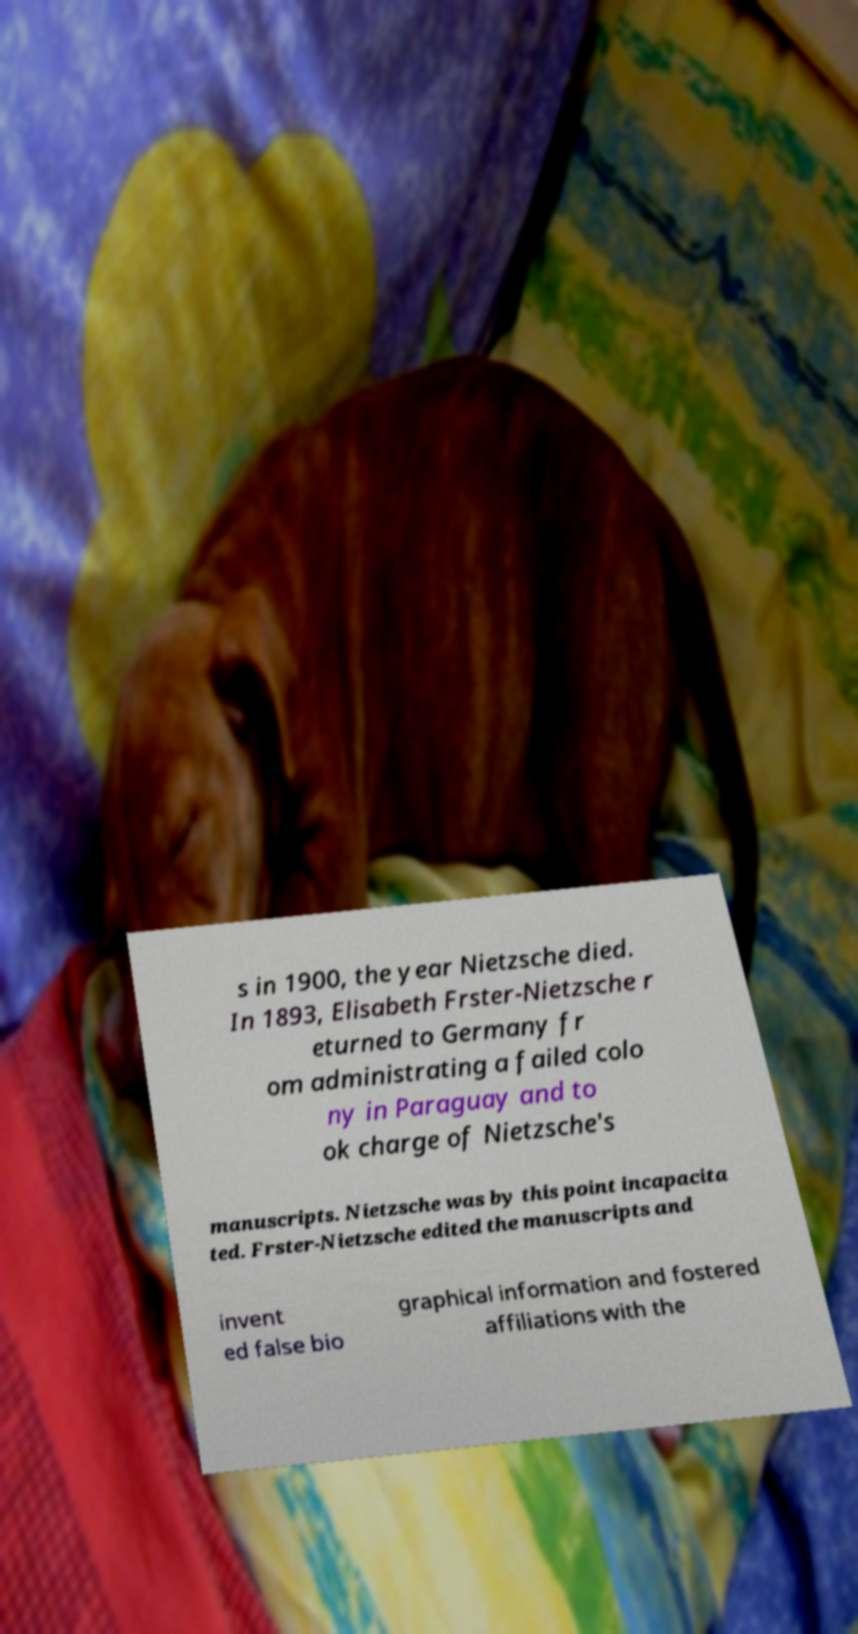Could you assist in decoding the text presented in this image and type it out clearly? s in 1900, the year Nietzsche died. In 1893, Elisabeth Frster-Nietzsche r eturned to Germany fr om administrating a failed colo ny in Paraguay and to ok charge of Nietzsche's manuscripts. Nietzsche was by this point incapacita ted. Frster-Nietzsche edited the manuscripts and invent ed false bio graphical information and fostered affiliations with the 